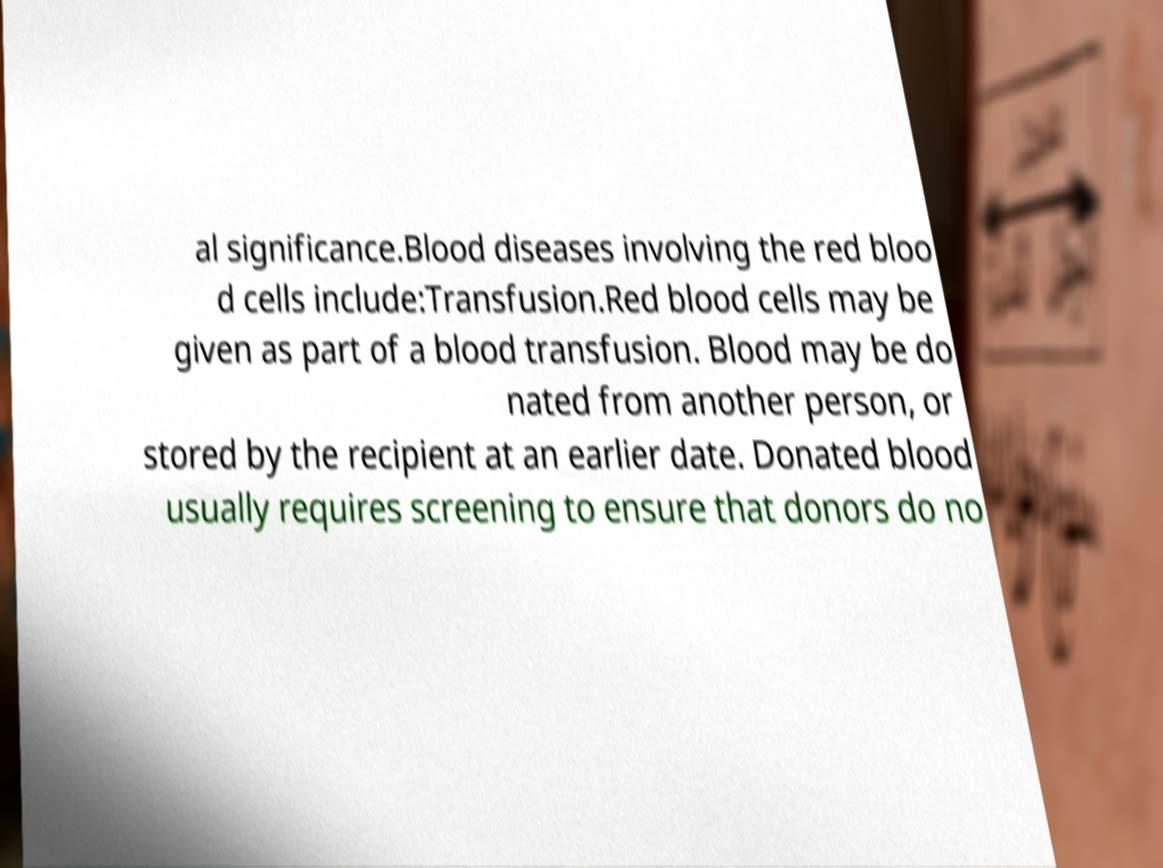Can you accurately transcribe the text from the provided image for me? al significance.Blood diseases involving the red bloo d cells include:Transfusion.Red blood cells may be given as part of a blood transfusion. Blood may be do nated from another person, or stored by the recipient at an earlier date. Donated blood usually requires screening to ensure that donors do no 